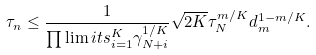<formula> <loc_0><loc_0><loc_500><loc_500>\tau _ { n } \leq \frac { 1 } { \prod \lim i t s _ { i = 1 } ^ { K } \gamma _ { N + i } ^ { 1 / K } } \sqrt { 2 K } \tau ^ { m / K } _ { N } d ^ { 1 - m / K } _ { m } .</formula> 